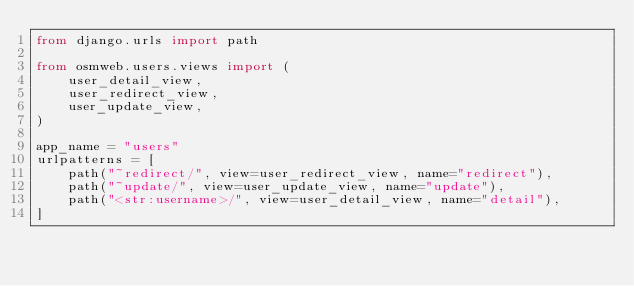Convert code to text. <code><loc_0><loc_0><loc_500><loc_500><_Python_>from django.urls import path

from osmweb.users.views import (
    user_detail_view,
    user_redirect_view,
    user_update_view,
)

app_name = "users"
urlpatterns = [
    path("~redirect/", view=user_redirect_view, name="redirect"),
    path("~update/", view=user_update_view, name="update"),
    path("<str:username>/", view=user_detail_view, name="detail"),
]
</code> 